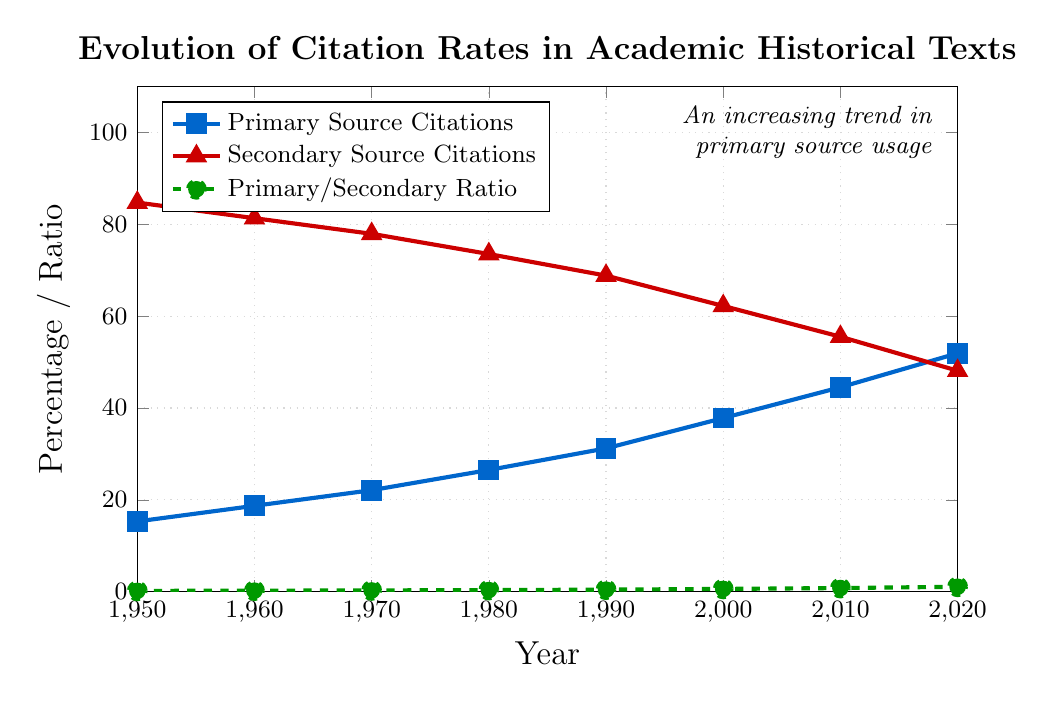Which year had the highest percentage of primary source citations? By observing the chart, the highest data point for primary source citations is found in the year 2020.
Answer: 2020 What was the primary/secondary citation ratio in 1980? Locate the value of the dashed green line in 1980 which represents the primary/secondary ratio. The value is 0.36.
Answer: 0.36 Between which two decades did the primary source citation percentage increase the most? Identify the decade intervals and calculate the differences between citation percentages: 
1960-1950: 18.7 - 15.3 = 3.4 
1970-1960: 22.1 - 18.7 = 3.4 
1980-1970: 26.5 - 22.1 = 4.4 
1990-1980: 31.2 - 26.5 = 4.7 
2000-1990: 37.8 - 31.2 = 6.6 
2010-2000: 44.5 - 37.8 = 6.7 
2020-2010: 51.9 - 44.5 = 7.4 
The largest difference is between 2010 and 2020.
Answer: 2010-2020 Compare the percentage of secondary source citations in 1970 to the percentage in 2000. The percentage in 1970 is 77.9% and in 2000 it's 62.2%. Subtract to find the difference: 77.9 - 62.2 = 15.7%.
Answer: 15.7% How many years did it take for the primary source citation percentage to surpass 50%? Determine when the primary source citation crossed 50% by examining the data points. This happened in 2020 and it started from 1950. The number of years from 1950 to 2020 is 2020 - 1950 = 70 years.
Answer: 70 years What is the trend in the primary/secondary ratio from 1950 to 2020? Observe the dashed green line representing the primary/secondary ratio. The ratio steadily increases from 0.18 in 1950 to 1.08 in 2020.
Answer: Increasing In which decade did secondary source citations drop below 70%? Identify when the secondary source citations fell below 70%, which happens between 1980 (73.5%) and 1990 (68.8%). Thus, it occurred in the 1980s.
Answer: 1980s 